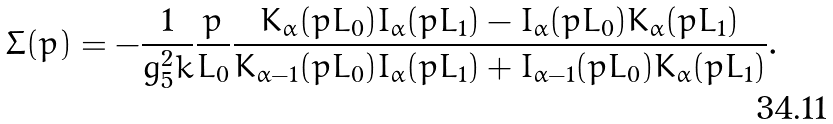Convert formula to latex. <formula><loc_0><loc_0><loc_500><loc_500>\Sigma ( p ) = - \frac { 1 } { g _ { 5 } ^ { 2 } k } \frac { p } { L _ { 0 } } \frac { K _ { \alpha } ( p L _ { 0 } ) I _ { \alpha } ( p L _ { 1 } ) - I _ { \alpha } ( p L _ { 0 } ) K _ { \alpha } ( p L _ { 1 } ) } { K _ { \alpha - 1 } ( p L _ { 0 } ) I _ { \alpha } ( p L _ { 1 } ) + I _ { \alpha - 1 } ( p L _ { 0 } ) K _ { \alpha } ( p L _ { 1 } ) } .</formula> 